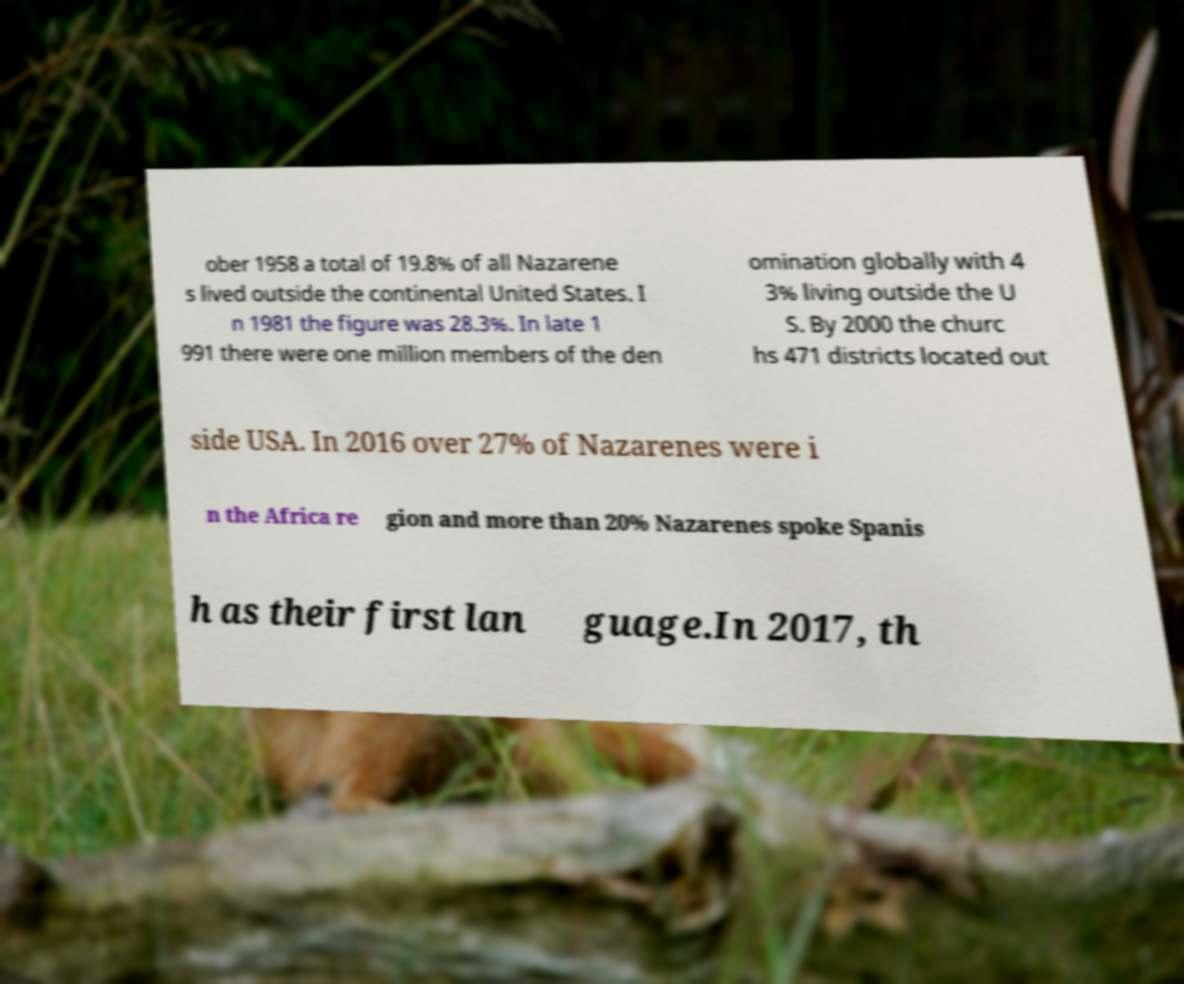For documentation purposes, I need the text within this image transcribed. Could you provide that? ober 1958 a total of 19.8% of all Nazarene s lived outside the continental United States. I n 1981 the figure was 28.3%. In late 1 991 there were one million members of the den omination globally with 4 3% living outside the U S. By 2000 the churc hs 471 districts located out side USA. In 2016 over 27% of Nazarenes were i n the Africa re gion and more than 20% Nazarenes spoke Spanis h as their first lan guage.In 2017, th 